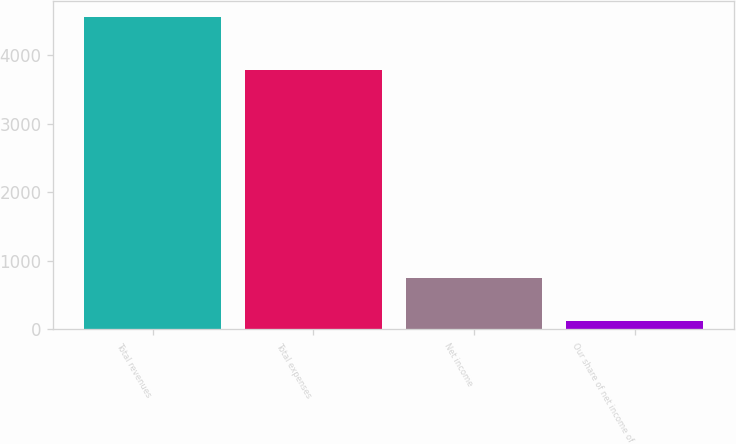Convert chart. <chart><loc_0><loc_0><loc_500><loc_500><bar_chart><fcel>Total revenues<fcel>Total expenses<fcel>Net income<fcel>Our share of net income of<nl><fcel>4555.9<fcel>3774.5<fcel>750.1<fcel>120.1<nl></chart> 